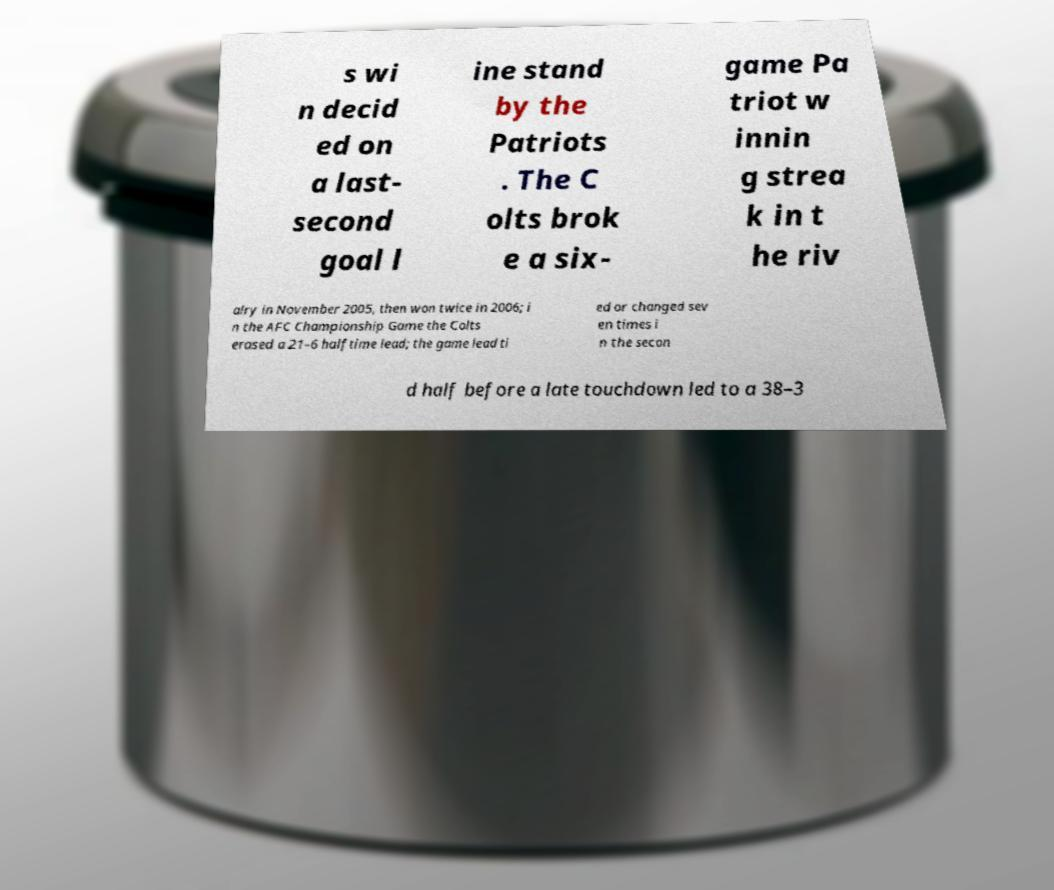I need the written content from this picture converted into text. Can you do that? s wi n decid ed on a last- second goal l ine stand by the Patriots . The C olts brok e a six- game Pa triot w innin g strea k in t he riv alry in November 2005, then won twice in 2006; i n the AFC Championship Game the Colts erased a 21–6 halftime lead; the game lead ti ed or changed sev en times i n the secon d half before a late touchdown led to a 38–3 